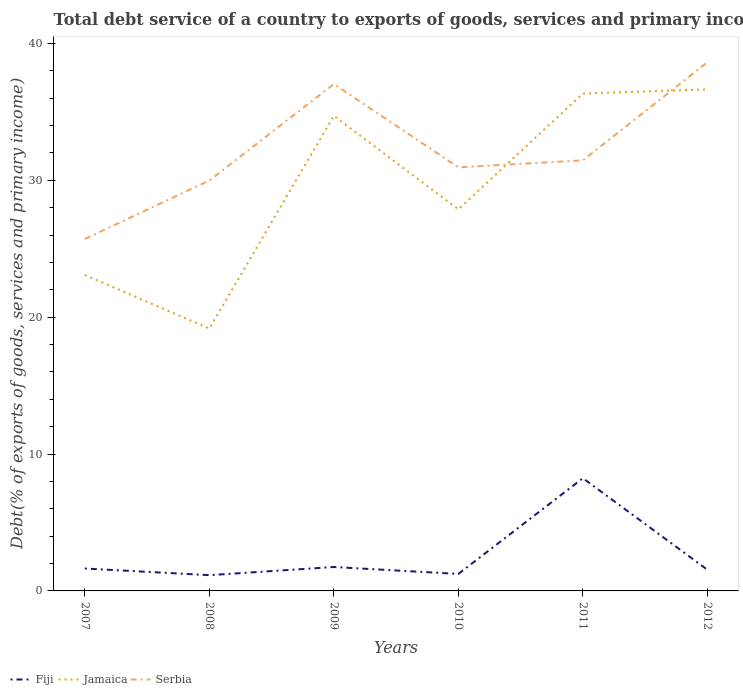Does the line corresponding to Jamaica intersect with the line corresponding to Fiji?
Keep it short and to the point. No. Is the number of lines equal to the number of legend labels?
Keep it short and to the point. Yes. Across all years, what is the maximum total debt service in Jamaica?
Offer a terse response. 19.17. What is the total total debt service in Jamaica in the graph?
Offer a very short reply. -15.55. What is the difference between the highest and the second highest total debt service in Serbia?
Provide a short and direct response. 12.91. How many lines are there?
Your answer should be compact. 3. Are the values on the major ticks of Y-axis written in scientific E-notation?
Offer a terse response. No. Does the graph contain grids?
Ensure brevity in your answer.  No. How are the legend labels stacked?
Offer a terse response. Horizontal. What is the title of the graph?
Make the answer very short. Total debt service of a country to exports of goods, services and primary income. Does "Ghana" appear as one of the legend labels in the graph?
Ensure brevity in your answer.  No. What is the label or title of the Y-axis?
Provide a succinct answer. Debt(% of exports of goods, services and primary income). What is the Debt(% of exports of goods, services and primary income) of Fiji in 2007?
Provide a short and direct response. 1.64. What is the Debt(% of exports of goods, services and primary income) of Jamaica in 2007?
Give a very brief answer. 23.08. What is the Debt(% of exports of goods, services and primary income) in Serbia in 2007?
Provide a short and direct response. 25.72. What is the Debt(% of exports of goods, services and primary income) of Fiji in 2008?
Offer a terse response. 1.15. What is the Debt(% of exports of goods, services and primary income) of Jamaica in 2008?
Provide a succinct answer. 19.17. What is the Debt(% of exports of goods, services and primary income) in Serbia in 2008?
Your answer should be compact. 29.99. What is the Debt(% of exports of goods, services and primary income) in Fiji in 2009?
Your answer should be very brief. 1.75. What is the Debt(% of exports of goods, services and primary income) in Jamaica in 2009?
Offer a terse response. 34.72. What is the Debt(% of exports of goods, services and primary income) in Serbia in 2009?
Give a very brief answer. 37.04. What is the Debt(% of exports of goods, services and primary income) in Fiji in 2010?
Provide a succinct answer. 1.24. What is the Debt(% of exports of goods, services and primary income) in Jamaica in 2010?
Your answer should be compact. 27.88. What is the Debt(% of exports of goods, services and primary income) in Serbia in 2010?
Ensure brevity in your answer.  30.95. What is the Debt(% of exports of goods, services and primary income) of Fiji in 2011?
Your response must be concise. 8.24. What is the Debt(% of exports of goods, services and primary income) in Jamaica in 2011?
Your answer should be compact. 36.34. What is the Debt(% of exports of goods, services and primary income) of Serbia in 2011?
Keep it short and to the point. 31.46. What is the Debt(% of exports of goods, services and primary income) of Fiji in 2012?
Provide a short and direct response. 1.55. What is the Debt(% of exports of goods, services and primary income) in Jamaica in 2012?
Offer a very short reply. 36.65. What is the Debt(% of exports of goods, services and primary income) in Serbia in 2012?
Provide a succinct answer. 38.63. Across all years, what is the maximum Debt(% of exports of goods, services and primary income) of Fiji?
Offer a terse response. 8.24. Across all years, what is the maximum Debt(% of exports of goods, services and primary income) in Jamaica?
Ensure brevity in your answer.  36.65. Across all years, what is the maximum Debt(% of exports of goods, services and primary income) of Serbia?
Give a very brief answer. 38.63. Across all years, what is the minimum Debt(% of exports of goods, services and primary income) in Fiji?
Provide a short and direct response. 1.15. Across all years, what is the minimum Debt(% of exports of goods, services and primary income) in Jamaica?
Provide a succinct answer. 19.17. Across all years, what is the minimum Debt(% of exports of goods, services and primary income) of Serbia?
Your answer should be very brief. 25.72. What is the total Debt(% of exports of goods, services and primary income) in Fiji in the graph?
Provide a succinct answer. 15.56. What is the total Debt(% of exports of goods, services and primary income) in Jamaica in the graph?
Your response must be concise. 177.84. What is the total Debt(% of exports of goods, services and primary income) in Serbia in the graph?
Your answer should be very brief. 193.78. What is the difference between the Debt(% of exports of goods, services and primary income) of Fiji in 2007 and that in 2008?
Offer a very short reply. 0.49. What is the difference between the Debt(% of exports of goods, services and primary income) of Jamaica in 2007 and that in 2008?
Provide a succinct answer. 3.91. What is the difference between the Debt(% of exports of goods, services and primary income) of Serbia in 2007 and that in 2008?
Your response must be concise. -4.27. What is the difference between the Debt(% of exports of goods, services and primary income) of Fiji in 2007 and that in 2009?
Your answer should be compact. -0.11. What is the difference between the Debt(% of exports of goods, services and primary income) in Jamaica in 2007 and that in 2009?
Keep it short and to the point. -11.63. What is the difference between the Debt(% of exports of goods, services and primary income) of Serbia in 2007 and that in 2009?
Make the answer very short. -11.32. What is the difference between the Debt(% of exports of goods, services and primary income) in Fiji in 2007 and that in 2010?
Give a very brief answer. 0.4. What is the difference between the Debt(% of exports of goods, services and primary income) of Jamaica in 2007 and that in 2010?
Give a very brief answer. -4.8. What is the difference between the Debt(% of exports of goods, services and primary income) in Serbia in 2007 and that in 2010?
Your answer should be compact. -5.23. What is the difference between the Debt(% of exports of goods, services and primary income) of Fiji in 2007 and that in 2011?
Make the answer very short. -6.6. What is the difference between the Debt(% of exports of goods, services and primary income) in Jamaica in 2007 and that in 2011?
Keep it short and to the point. -13.26. What is the difference between the Debt(% of exports of goods, services and primary income) in Serbia in 2007 and that in 2011?
Keep it short and to the point. -5.74. What is the difference between the Debt(% of exports of goods, services and primary income) of Fiji in 2007 and that in 2012?
Your answer should be very brief. 0.09. What is the difference between the Debt(% of exports of goods, services and primary income) of Jamaica in 2007 and that in 2012?
Give a very brief answer. -13.56. What is the difference between the Debt(% of exports of goods, services and primary income) of Serbia in 2007 and that in 2012?
Your answer should be compact. -12.91. What is the difference between the Debt(% of exports of goods, services and primary income) of Fiji in 2008 and that in 2009?
Your answer should be compact. -0.6. What is the difference between the Debt(% of exports of goods, services and primary income) in Jamaica in 2008 and that in 2009?
Your answer should be very brief. -15.55. What is the difference between the Debt(% of exports of goods, services and primary income) of Serbia in 2008 and that in 2009?
Ensure brevity in your answer.  -7.05. What is the difference between the Debt(% of exports of goods, services and primary income) in Fiji in 2008 and that in 2010?
Keep it short and to the point. -0.09. What is the difference between the Debt(% of exports of goods, services and primary income) in Jamaica in 2008 and that in 2010?
Your response must be concise. -8.71. What is the difference between the Debt(% of exports of goods, services and primary income) of Serbia in 2008 and that in 2010?
Your answer should be very brief. -0.96. What is the difference between the Debt(% of exports of goods, services and primary income) of Fiji in 2008 and that in 2011?
Provide a short and direct response. -7.09. What is the difference between the Debt(% of exports of goods, services and primary income) in Jamaica in 2008 and that in 2011?
Provide a short and direct response. -17.17. What is the difference between the Debt(% of exports of goods, services and primary income) of Serbia in 2008 and that in 2011?
Make the answer very short. -1.48. What is the difference between the Debt(% of exports of goods, services and primary income) in Fiji in 2008 and that in 2012?
Make the answer very short. -0.4. What is the difference between the Debt(% of exports of goods, services and primary income) in Jamaica in 2008 and that in 2012?
Give a very brief answer. -17.48. What is the difference between the Debt(% of exports of goods, services and primary income) of Serbia in 2008 and that in 2012?
Your response must be concise. -8.64. What is the difference between the Debt(% of exports of goods, services and primary income) in Fiji in 2009 and that in 2010?
Offer a very short reply. 0.51. What is the difference between the Debt(% of exports of goods, services and primary income) of Jamaica in 2009 and that in 2010?
Give a very brief answer. 6.83. What is the difference between the Debt(% of exports of goods, services and primary income) in Serbia in 2009 and that in 2010?
Make the answer very short. 6.09. What is the difference between the Debt(% of exports of goods, services and primary income) of Fiji in 2009 and that in 2011?
Keep it short and to the point. -6.49. What is the difference between the Debt(% of exports of goods, services and primary income) in Jamaica in 2009 and that in 2011?
Provide a succinct answer. -1.63. What is the difference between the Debt(% of exports of goods, services and primary income) of Serbia in 2009 and that in 2011?
Your answer should be very brief. 5.58. What is the difference between the Debt(% of exports of goods, services and primary income) in Fiji in 2009 and that in 2012?
Make the answer very short. 0.2. What is the difference between the Debt(% of exports of goods, services and primary income) of Jamaica in 2009 and that in 2012?
Make the answer very short. -1.93. What is the difference between the Debt(% of exports of goods, services and primary income) in Serbia in 2009 and that in 2012?
Provide a succinct answer. -1.59. What is the difference between the Debt(% of exports of goods, services and primary income) of Fiji in 2010 and that in 2011?
Make the answer very short. -7. What is the difference between the Debt(% of exports of goods, services and primary income) of Jamaica in 2010 and that in 2011?
Offer a terse response. -8.46. What is the difference between the Debt(% of exports of goods, services and primary income) in Serbia in 2010 and that in 2011?
Ensure brevity in your answer.  -0.51. What is the difference between the Debt(% of exports of goods, services and primary income) of Fiji in 2010 and that in 2012?
Keep it short and to the point. -0.31. What is the difference between the Debt(% of exports of goods, services and primary income) of Jamaica in 2010 and that in 2012?
Offer a terse response. -8.76. What is the difference between the Debt(% of exports of goods, services and primary income) of Serbia in 2010 and that in 2012?
Your response must be concise. -7.68. What is the difference between the Debt(% of exports of goods, services and primary income) of Fiji in 2011 and that in 2012?
Ensure brevity in your answer.  6.69. What is the difference between the Debt(% of exports of goods, services and primary income) of Jamaica in 2011 and that in 2012?
Make the answer very short. -0.3. What is the difference between the Debt(% of exports of goods, services and primary income) of Serbia in 2011 and that in 2012?
Offer a terse response. -7.17. What is the difference between the Debt(% of exports of goods, services and primary income) of Fiji in 2007 and the Debt(% of exports of goods, services and primary income) of Jamaica in 2008?
Provide a succinct answer. -17.53. What is the difference between the Debt(% of exports of goods, services and primary income) of Fiji in 2007 and the Debt(% of exports of goods, services and primary income) of Serbia in 2008?
Provide a succinct answer. -28.35. What is the difference between the Debt(% of exports of goods, services and primary income) of Jamaica in 2007 and the Debt(% of exports of goods, services and primary income) of Serbia in 2008?
Your response must be concise. -6.9. What is the difference between the Debt(% of exports of goods, services and primary income) in Fiji in 2007 and the Debt(% of exports of goods, services and primary income) in Jamaica in 2009?
Keep it short and to the point. -33.08. What is the difference between the Debt(% of exports of goods, services and primary income) in Fiji in 2007 and the Debt(% of exports of goods, services and primary income) in Serbia in 2009?
Offer a very short reply. -35.4. What is the difference between the Debt(% of exports of goods, services and primary income) in Jamaica in 2007 and the Debt(% of exports of goods, services and primary income) in Serbia in 2009?
Offer a terse response. -13.95. What is the difference between the Debt(% of exports of goods, services and primary income) in Fiji in 2007 and the Debt(% of exports of goods, services and primary income) in Jamaica in 2010?
Your answer should be very brief. -26.24. What is the difference between the Debt(% of exports of goods, services and primary income) of Fiji in 2007 and the Debt(% of exports of goods, services and primary income) of Serbia in 2010?
Give a very brief answer. -29.31. What is the difference between the Debt(% of exports of goods, services and primary income) of Jamaica in 2007 and the Debt(% of exports of goods, services and primary income) of Serbia in 2010?
Make the answer very short. -7.87. What is the difference between the Debt(% of exports of goods, services and primary income) in Fiji in 2007 and the Debt(% of exports of goods, services and primary income) in Jamaica in 2011?
Make the answer very short. -34.7. What is the difference between the Debt(% of exports of goods, services and primary income) in Fiji in 2007 and the Debt(% of exports of goods, services and primary income) in Serbia in 2011?
Provide a short and direct response. -29.82. What is the difference between the Debt(% of exports of goods, services and primary income) in Jamaica in 2007 and the Debt(% of exports of goods, services and primary income) in Serbia in 2011?
Keep it short and to the point. -8.38. What is the difference between the Debt(% of exports of goods, services and primary income) in Fiji in 2007 and the Debt(% of exports of goods, services and primary income) in Jamaica in 2012?
Keep it short and to the point. -35.01. What is the difference between the Debt(% of exports of goods, services and primary income) of Fiji in 2007 and the Debt(% of exports of goods, services and primary income) of Serbia in 2012?
Keep it short and to the point. -36.99. What is the difference between the Debt(% of exports of goods, services and primary income) in Jamaica in 2007 and the Debt(% of exports of goods, services and primary income) in Serbia in 2012?
Keep it short and to the point. -15.55. What is the difference between the Debt(% of exports of goods, services and primary income) in Fiji in 2008 and the Debt(% of exports of goods, services and primary income) in Jamaica in 2009?
Ensure brevity in your answer.  -33.56. What is the difference between the Debt(% of exports of goods, services and primary income) in Fiji in 2008 and the Debt(% of exports of goods, services and primary income) in Serbia in 2009?
Give a very brief answer. -35.89. What is the difference between the Debt(% of exports of goods, services and primary income) of Jamaica in 2008 and the Debt(% of exports of goods, services and primary income) of Serbia in 2009?
Give a very brief answer. -17.87. What is the difference between the Debt(% of exports of goods, services and primary income) of Fiji in 2008 and the Debt(% of exports of goods, services and primary income) of Jamaica in 2010?
Keep it short and to the point. -26.73. What is the difference between the Debt(% of exports of goods, services and primary income) of Fiji in 2008 and the Debt(% of exports of goods, services and primary income) of Serbia in 2010?
Your response must be concise. -29.8. What is the difference between the Debt(% of exports of goods, services and primary income) of Jamaica in 2008 and the Debt(% of exports of goods, services and primary income) of Serbia in 2010?
Keep it short and to the point. -11.78. What is the difference between the Debt(% of exports of goods, services and primary income) of Fiji in 2008 and the Debt(% of exports of goods, services and primary income) of Jamaica in 2011?
Your answer should be very brief. -35.19. What is the difference between the Debt(% of exports of goods, services and primary income) in Fiji in 2008 and the Debt(% of exports of goods, services and primary income) in Serbia in 2011?
Provide a succinct answer. -30.31. What is the difference between the Debt(% of exports of goods, services and primary income) of Jamaica in 2008 and the Debt(% of exports of goods, services and primary income) of Serbia in 2011?
Your response must be concise. -12.29. What is the difference between the Debt(% of exports of goods, services and primary income) in Fiji in 2008 and the Debt(% of exports of goods, services and primary income) in Jamaica in 2012?
Provide a succinct answer. -35.49. What is the difference between the Debt(% of exports of goods, services and primary income) in Fiji in 2008 and the Debt(% of exports of goods, services and primary income) in Serbia in 2012?
Offer a very short reply. -37.48. What is the difference between the Debt(% of exports of goods, services and primary income) of Jamaica in 2008 and the Debt(% of exports of goods, services and primary income) of Serbia in 2012?
Keep it short and to the point. -19.46. What is the difference between the Debt(% of exports of goods, services and primary income) of Fiji in 2009 and the Debt(% of exports of goods, services and primary income) of Jamaica in 2010?
Give a very brief answer. -26.13. What is the difference between the Debt(% of exports of goods, services and primary income) in Fiji in 2009 and the Debt(% of exports of goods, services and primary income) in Serbia in 2010?
Provide a short and direct response. -29.2. What is the difference between the Debt(% of exports of goods, services and primary income) of Jamaica in 2009 and the Debt(% of exports of goods, services and primary income) of Serbia in 2010?
Give a very brief answer. 3.77. What is the difference between the Debt(% of exports of goods, services and primary income) of Fiji in 2009 and the Debt(% of exports of goods, services and primary income) of Jamaica in 2011?
Offer a terse response. -34.59. What is the difference between the Debt(% of exports of goods, services and primary income) of Fiji in 2009 and the Debt(% of exports of goods, services and primary income) of Serbia in 2011?
Give a very brief answer. -29.71. What is the difference between the Debt(% of exports of goods, services and primary income) in Jamaica in 2009 and the Debt(% of exports of goods, services and primary income) in Serbia in 2011?
Your answer should be very brief. 3.25. What is the difference between the Debt(% of exports of goods, services and primary income) of Fiji in 2009 and the Debt(% of exports of goods, services and primary income) of Jamaica in 2012?
Ensure brevity in your answer.  -34.9. What is the difference between the Debt(% of exports of goods, services and primary income) of Fiji in 2009 and the Debt(% of exports of goods, services and primary income) of Serbia in 2012?
Provide a succinct answer. -36.88. What is the difference between the Debt(% of exports of goods, services and primary income) in Jamaica in 2009 and the Debt(% of exports of goods, services and primary income) in Serbia in 2012?
Provide a succinct answer. -3.91. What is the difference between the Debt(% of exports of goods, services and primary income) of Fiji in 2010 and the Debt(% of exports of goods, services and primary income) of Jamaica in 2011?
Your response must be concise. -35.1. What is the difference between the Debt(% of exports of goods, services and primary income) of Fiji in 2010 and the Debt(% of exports of goods, services and primary income) of Serbia in 2011?
Ensure brevity in your answer.  -30.22. What is the difference between the Debt(% of exports of goods, services and primary income) in Jamaica in 2010 and the Debt(% of exports of goods, services and primary income) in Serbia in 2011?
Provide a succinct answer. -3.58. What is the difference between the Debt(% of exports of goods, services and primary income) of Fiji in 2010 and the Debt(% of exports of goods, services and primary income) of Jamaica in 2012?
Your answer should be very brief. -35.4. What is the difference between the Debt(% of exports of goods, services and primary income) of Fiji in 2010 and the Debt(% of exports of goods, services and primary income) of Serbia in 2012?
Offer a terse response. -37.39. What is the difference between the Debt(% of exports of goods, services and primary income) of Jamaica in 2010 and the Debt(% of exports of goods, services and primary income) of Serbia in 2012?
Ensure brevity in your answer.  -10.75. What is the difference between the Debt(% of exports of goods, services and primary income) of Fiji in 2011 and the Debt(% of exports of goods, services and primary income) of Jamaica in 2012?
Offer a very short reply. -28.41. What is the difference between the Debt(% of exports of goods, services and primary income) in Fiji in 2011 and the Debt(% of exports of goods, services and primary income) in Serbia in 2012?
Ensure brevity in your answer.  -30.39. What is the difference between the Debt(% of exports of goods, services and primary income) in Jamaica in 2011 and the Debt(% of exports of goods, services and primary income) in Serbia in 2012?
Offer a terse response. -2.29. What is the average Debt(% of exports of goods, services and primary income) of Fiji per year?
Your answer should be compact. 2.59. What is the average Debt(% of exports of goods, services and primary income) in Jamaica per year?
Offer a terse response. 29.64. What is the average Debt(% of exports of goods, services and primary income) in Serbia per year?
Your answer should be very brief. 32.3. In the year 2007, what is the difference between the Debt(% of exports of goods, services and primary income) of Fiji and Debt(% of exports of goods, services and primary income) of Jamaica?
Provide a short and direct response. -21.45. In the year 2007, what is the difference between the Debt(% of exports of goods, services and primary income) of Fiji and Debt(% of exports of goods, services and primary income) of Serbia?
Make the answer very short. -24.08. In the year 2007, what is the difference between the Debt(% of exports of goods, services and primary income) in Jamaica and Debt(% of exports of goods, services and primary income) in Serbia?
Offer a terse response. -2.64. In the year 2008, what is the difference between the Debt(% of exports of goods, services and primary income) in Fiji and Debt(% of exports of goods, services and primary income) in Jamaica?
Your response must be concise. -18.02. In the year 2008, what is the difference between the Debt(% of exports of goods, services and primary income) in Fiji and Debt(% of exports of goods, services and primary income) in Serbia?
Give a very brief answer. -28.83. In the year 2008, what is the difference between the Debt(% of exports of goods, services and primary income) in Jamaica and Debt(% of exports of goods, services and primary income) in Serbia?
Your answer should be compact. -10.81. In the year 2009, what is the difference between the Debt(% of exports of goods, services and primary income) of Fiji and Debt(% of exports of goods, services and primary income) of Jamaica?
Give a very brief answer. -32.97. In the year 2009, what is the difference between the Debt(% of exports of goods, services and primary income) of Fiji and Debt(% of exports of goods, services and primary income) of Serbia?
Offer a very short reply. -35.29. In the year 2009, what is the difference between the Debt(% of exports of goods, services and primary income) in Jamaica and Debt(% of exports of goods, services and primary income) in Serbia?
Give a very brief answer. -2.32. In the year 2010, what is the difference between the Debt(% of exports of goods, services and primary income) in Fiji and Debt(% of exports of goods, services and primary income) in Jamaica?
Provide a succinct answer. -26.64. In the year 2010, what is the difference between the Debt(% of exports of goods, services and primary income) of Fiji and Debt(% of exports of goods, services and primary income) of Serbia?
Provide a succinct answer. -29.71. In the year 2010, what is the difference between the Debt(% of exports of goods, services and primary income) in Jamaica and Debt(% of exports of goods, services and primary income) in Serbia?
Provide a short and direct response. -3.07. In the year 2011, what is the difference between the Debt(% of exports of goods, services and primary income) in Fiji and Debt(% of exports of goods, services and primary income) in Jamaica?
Provide a short and direct response. -28.11. In the year 2011, what is the difference between the Debt(% of exports of goods, services and primary income) in Fiji and Debt(% of exports of goods, services and primary income) in Serbia?
Give a very brief answer. -23.22. In the year 2011, what is the difference between the Debt(% of exports of goods, services and primary income) in Jamaica and Debt(% of exports of goods, services and primary income) in Serbia?
Provide a succinct answer. 4.88. In the year 2012, what is the difference between the Debt(% of exports of goods, services and primary income) of Fiji and Debt(% of exports of goods, services and primary income) of Jamaica?
Your answer should be compact. -35.1. In the year 2012, what is the difference between the Debt(% of exports of goods, services and primary income) of Fiji and Debt(% of exports of goods, services and primary income) of Serbia?
Provide a succinct answer. -37.08. In the year 2012, what is the difference between the Debt(% of exports of goods, services and primary income) in Jamaica and Debt(% of exports of goods, services and primary income) in Serbia?
Offer a terse response. -1.98. What is the ratio of the Debt(% of exports of goods, services and primary income) in Fiji in 2007 to that in 2008?
Give a very brief answer. 1.42. What is the ratio of the Debt(% of exports of goods, services and primary income) of Jamaica in 2007 to that in 2008?
Keep it short and to the point. 1.2. What is the ratio of the Debt(% of exports of goods, services and primary income) in Serbia in 2007 to that in 2008?
Your answer should be compact. 0.86. What is the ratio of the Debt(% of exports of goods, services and primary income) of Fiji in 2007 to that in 2009?
Ensure brevity in your answer.  0.94. What is the ratio of the Debt(% of exports of goods, services and primary income) of Jamaica in 2007 to that in 2009?
Ensure brevity in your answer.  0.66. What is the ratio of the Debt(% of exports of goods, services and primary income) of Serbia in 2007 to that in 2009?
Provide a succinct answer. 0.69. What is the ratio of the Debt(% of exports of goods, services and primary income) in Fiji in 2007 to that in 2010?
Keep it short and to the point. 1.32. What is the ratio of the Debt(% of exports of goods, services and primary income) in Jamaica in 2007 to that in 2010?
Your answer should be very brief. 0.83. What is the ratio of the Debt(% of exports of goods, services and primary income) of Serbia in 2007 to that in 2010?
Your response must be concise. 0.83. What is the ratio of the Debt(% of exports of goods, services and primary income) in Fiji in 2007 to that in 2011?
Give a very brief answer. 0.2. What is the ratio of the Debt(% of exports of goods, services and primary income) in Jamaica in 2007 to that in 2011?
Give a very brief answer. 0.64. What is the ratio of the Debt(% of exports of goods, services and primary income) of Serbia in 2007 to that in 2011?
Offer a very short reply. 0.82. What is the ratio of the Debt(% of exports of goods, services and primary income) of Fiji in 2007 to that in 2012?
Offer a very short reply. 1.06. What is the ratio of the Debt(% of exports of goods, services and primary income) of Jamaica in 2007 to that in 2012?
Offer a very short reply. 0.63. What is the ratio of the Debt(% of exports of goods, services and primary income) in Serbia in 2007 to that in 2012?
Provide a succinct answer. 0.67. What is the ratio of the Debt(% of exports of goods, services and primary income) of Fiji in 2008 to that in 2009?
Ensure brevity in your answer.  0.66. What is the ratio of the Debt(% of exports of goods, services and primary income) in Jamaica in 2008 to that in 2009?
Your answer should be compact. 0.55. What is the ratio of the Debt(% of exports of goods, services and primary income) of Serbia in 2008 to that in 2009?
Provide a short and direct response. 0.81. What is the ratio of the Debt(% of exports of goods, services and primary income) of Fiji in 2008 to that in 2010?
Offer a very short reply. 0.93. What is the ratio of the Debt(% of exports of goods, services and primary income) in Jamaica in 2008 to that in 2010?
Your answer should be compact. 0.69. What is the ratio of the Debt(% of exports of goods, services and primary income) in Serbia in 2008 to that in 2010?
Keep it short and to the point. 0.97. What is the ratio of the Debt(% of exports of goods, services and primary income) in Fiji in 2008 to that in 2011?
Keep it short and to the point. 0.14. What is the ratio of the Debt(% of exports of goods, services and primary income) of Jamaica in 2008 to that in 2011?
Provide a succinct answer. 0.53. What is the ratio of the Debt(% of exports of goods, services and primary income) of Serbia in 2008 to that in 2011?
Your answer should be compact. 0.95. What is the ratio of the Debt(% of exports of goods, services and primary income) of Fiji in 2008 to that in 2012?
Keep it short and to the point. 0.74. What is the ratio of the Debt(% of exports of goods, services and primary income) in Jamaica in 2008 to that in 2012?
Your response must be concise. 0.52. What is the ratio of the Debt(% of exports of goods, services and primary income) of Serbia in 2008 to that in 2012?
Ensure brevity in your answer.  0.78. What is the ratio of the Debt(% of exports of goods, services and primary income) of Fiji in 2009 to that in 2010?
Give a very brief answer. 1.41. What is the ratio of the Debt(% of exports of goods, services and primary income) in Jamaica in 2009 to that in 2010?
Provide a succinct answer. 1.25. What is the ratio of the Debt(% of exports of goods, services and primary income) of Serbia in 2009 to that in 2010?
Your answer should be compact. 1.2. What is the ratio of the Debt(% of exports of goods, services and primary income) of Fiji in 2009 to that in 2011?
Offer a very short reply. 0.21. What is the ratio of the Debt(% of exports of goods, services and primary income) of Jamaica in 2009 to that in 2011?
Keep it short and to the point. 0.96. What is the ratio of the Debt(% of exports of goods, services and primary income) in Serbia in 2009 to that in 2011?
Your answer should be very brief. 1.18. What is the ratio of the Debt(% of exports of goods, services and primary income) in Fiji in 2009 to that in 2012?
Offer a very short reply. 1.13. What is the ratio of the Debt(% of exports of goods, services and primary income) of Jamaica in 2009 to that in 2012?
Your answer should be compact. 0.95. What is the ratio of the Debt(% of exports of goods, services and primary income) of Serbia in 2009 to that in 2012?
Your answer should be compact. 0.96. What is the ratio of the Debt(% of exports of goods, services and primary income) in Fiji in 2010 to that in 2011?
Make the answer very short. 0.15. What is the ratio of the Debt(% of exports of goods, services and primary income) of Jamaica in 2010 to that in 2011?
Your response must be concise. 0.77. What is the ratio of the Debt(% of exports of goods, services and primary income) in Serbia in 2010 to that in 2011?
Provide a succinct answer. 0.98. What is the ratio of the Debt(% of exports of goods, services and primary income) in Fiji in 2010 to that in 2012?
Provide a succinct answer. 0.8. What is the ratio of the Debt(% of exports of goods, services and primary income) in Jamaica in 2010 to that in 2012?
Your answer should be very brief. 0.76. What is the ratio of the Debt(% of exports of goods, services and primary income) in Serbia in 2010 to that in 2012?
Keep it short and to the point. 0.8. What is the ratio of the Debt(% of exports of goods, services and primary income) in Fiji in 2011 to that in 2012?
Your answer should be compact. 5.32. What is the ratio of the Debt(% of exports of goods, services and primary income) of Jamaica in 2011 to that in 2012?
Provide a short and direct response. 0.99. What is the ratio of the Debt(% of exports of goods, services and primary income) of Serbia in 2011 to that in 2012?
Make the answer very short. 0.81. What is the difference between the highest and the second highest Debt(% of exports of goods, services and primary income) in Fiji?
Offer a terse response. 6.49. What is the difference between the highest and the second highest Debt(% of exports of goods, services and primary income) of Jamaica?
Offer a terse response. 0.3. What is the difference between the highest and the second highest Debt(% of exports of goods, services and primary income) of Serbia?
Provide a succinct answer. 1.59. What is the difference between the highest and the lowest Debt(% of exports of goods, services and primary income) of Fiji?
Give a very brief answer. 7.09. What is the difference between the highest and the lowest Debt(% of exports of goods, services and primary income) of Jamaica?
Your response must be concise. 17.48. What is the difference between the highest and the lowest Debt(% of exports of goods, services and primary income) in Serbia?
Your answer should be compact. 12.91. 